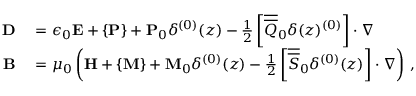<formula> <loc_0><loc_0><loc_500><loc_500>\begin{array} { r l } { D } & = \epsilon _ { 0 } E + \{ P \} + P _ { 0 } \delta ^ { ( 0 ) } ( z ) - \frac { 1 } { 2 } \left [ \overline { { \overline { Q } } } _ { 0 } \delta ( z ) ^ { ( 0 ) } \right ] \cdot \nabla } \\ { B } & = \mu _ { 0 } \left ( H + \{ M \} + M _ { 0 } \delta ^ { ( 0 ) } ( z ) - \frac { 1 } { 2 } \left [ \overline { { \overline { S } } } _ { 0 } \delta ^ { ( 0 ) } ( z ) \right ] \cdot \nabla \right ) \, , } \end{array}</formula> 